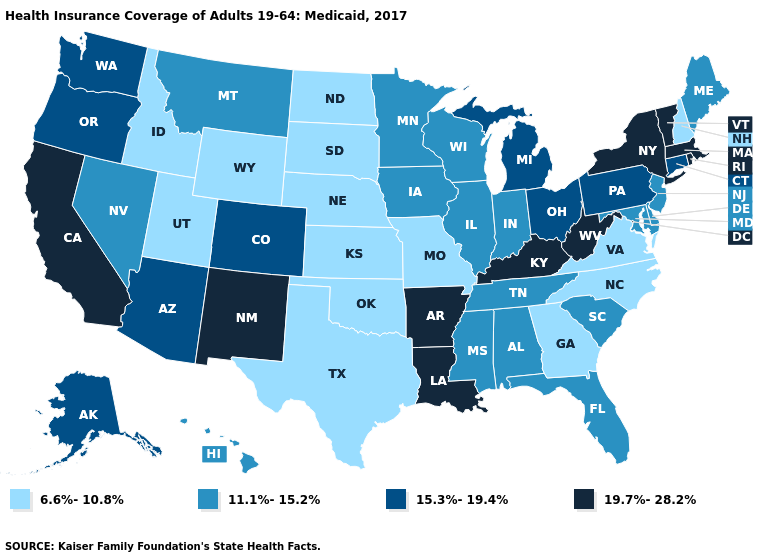Which states have the highest value in the USA?
Be succinct. Arkansas, California, Kentucky, Louisiana, Massachusetts, New Mexico, New York, Rhode Island, Vermont, West Virginia. What is the value of Tennessee?
Write a very short answer. 11.1%-15.2%. What is the highest value in the South ?
Concise answer only. 19.7%-28.2%. What is the value of Arkansas?
Write a very short answer. 19.7%-28.2%. Name the states that have a value in the range 19.7%-28.2%?
Write a very short answer. Arkansas, California, Kentucky, Louisiana, Massachusetts, New Mexico, New York, Rhode Island, Vermont, West Virginia. Does Texas have the lowest value in the USA?
Concise answer only. Yes. Among the states that border Massachusetts , does Rhode Island have the highest value?
Concise answer only. Yes. Name the states that have a value in the range 15.3%-19.4%?
Answer briefly. Alaska, Arizona, Colorado, Connecticut, Michigan, Ohio, Oregon, Pennsylvania, Washington. Among the states that border New York , does Connecticut have the highest value?
Answer briefly. No. What is the lowest value in states that border New Jersey?
Short answer required. 11.1%-15.2%. Does Rhode Island have the highest value in the Northeast?
Short answer required. Yes. What is the highest value in the USA?
Keep it brief. 19.7%-28.2%. Does Arkansas have the highest value in the South?
Give a very brief answer. Yes. What is the lowest value in the MidWest?
Write a very short answer. 6.6%-10.8%. 